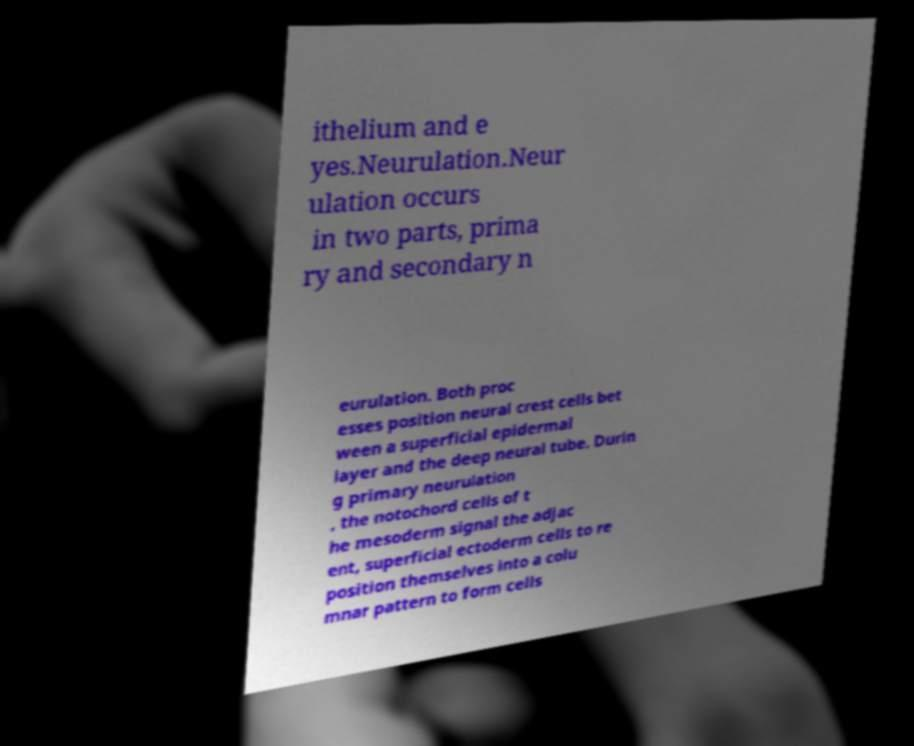Can you accurately transcribe the text from the provided image for me? ithelium and e yes.Neurulation.Neur ulation occurs in two parts, prima ry and secondary n eurulation. Both proc esses position neural crest cells bet ween a superficial epidermal layer and the deep neural tube. Durin g primary neurulation , the notochord cells of t he mesoderm signal the adjac ent, superficial ectoderm cells to re position themselves into a colu mnar pattern to form cells 